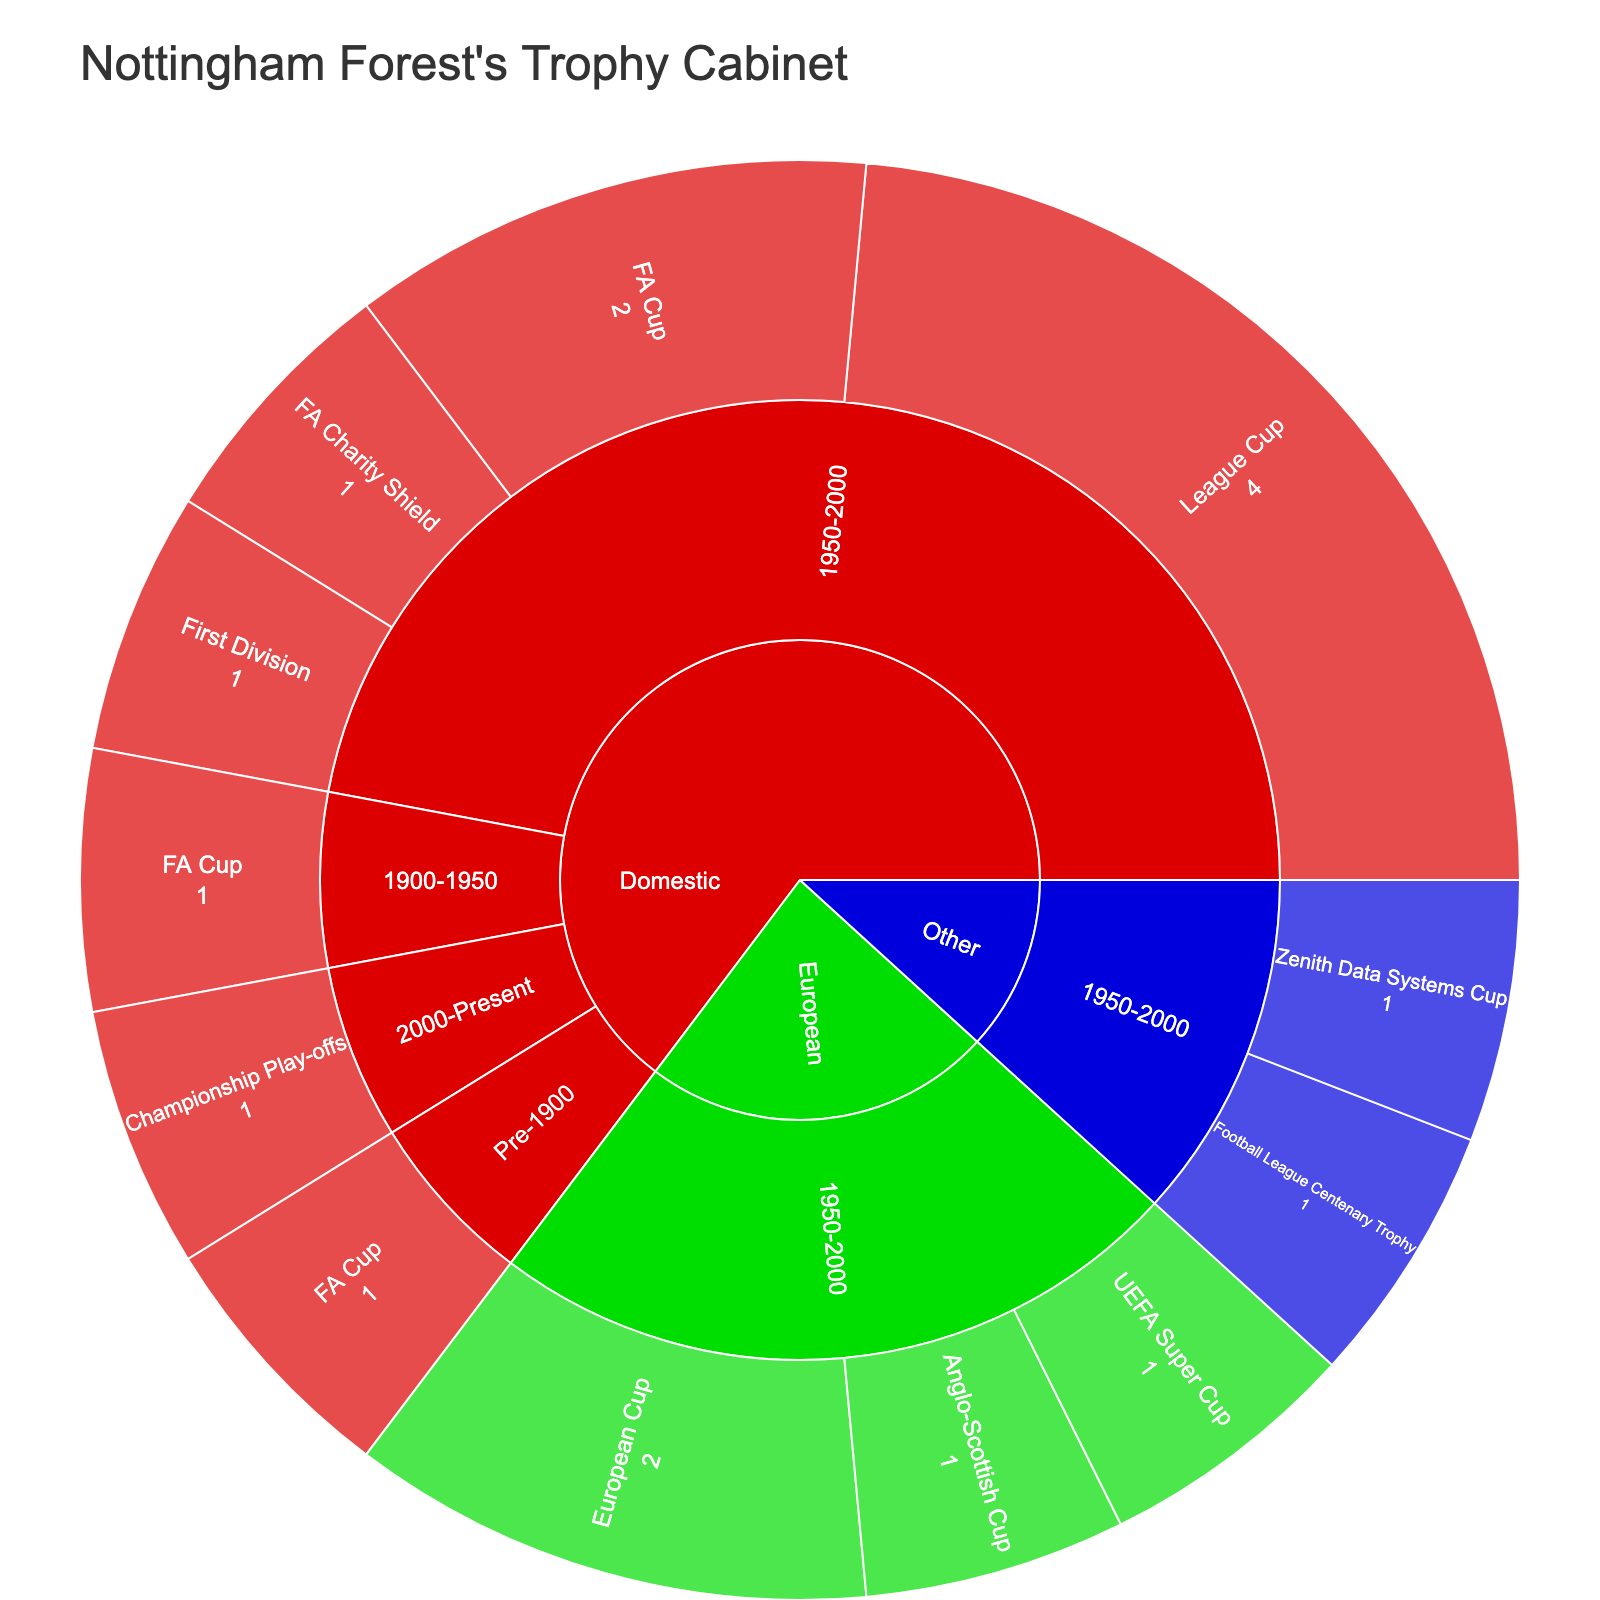What's the title of the Sunburst Plot? The title is usually displayed at the top of the chart. It provides an overall summary of the data being visualized. In this case, the title would be related to Nottingham Forest's achievements.
Answer: Nottingham Forest's Trophy Cabinet How many FA Cups has Nottingham Forest won between 1950-2000? Locate the Domestic section, then navigate to the era 1950-2000, and look for the FA Cup segment. The count provided in this segment is the number of FA Cups won during this period.
Answer: 2 Which era features the FA Charity Shield in the Domestic competition? Navigate to the Domestic section and observe the eras listed under it. Identify the era that includes the FA Charity Shield trophy.
Answer: 1950-2000 How many European trophies did Nottingham Forest win in total? Search for the European section. Sum the counts of all trophies listed under any eras within that section.
Answer: 4 Which competition has a unique color compared to Domestic and European? Observe the color-coded sections representing different competitions on the Sunburst Plot. Identify which section's color differs from Domestic and European.
Answer: Other In which era did Nottingham Forest win the most League Cups? Locate the Domestic section and filter by different eras. Find the era with the highest count of League Cups won.
Answer: 1950-2000 What is the total number of trophies Nottingham Forest won in the Domestic competition? Sum up the counts of all trophies under the Domestic competition for all eras combined.
Answer: 10 Between Domestic and European competitions, which has more trophies won by Nottingham Forest? Compare the total counts of trophies in the Domestic section with those in the European section. Identify which has a higher total count.
Answer: Domestic What specific European trophy did Nottingham Forest win only once between 1950-2000? Navigate to the European section, look for the era 1950-2000, and identify the trophy that appears with a count of one.
Answer: UEFA Super Cup How many trophies did Nottingham Forest win during the Pre-1900 era? Locate the era labeled Pre-1900 and sum the counts of all trophies listed under this era.
Answer: 1 